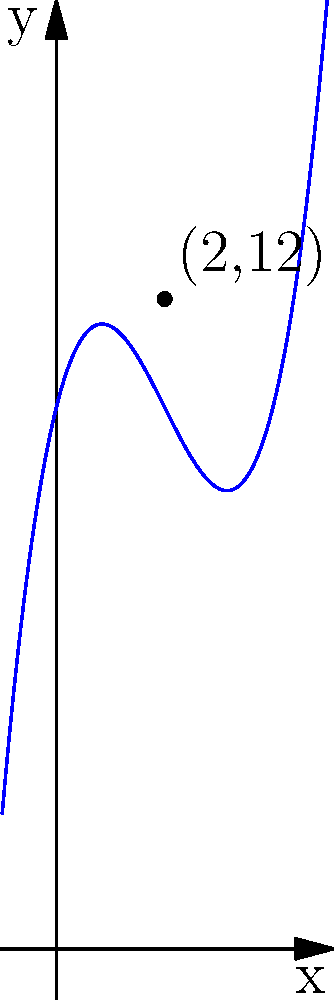A prestigious library's rare manuscript collection is growing according to the cubic function $f(x) = 0.5x^3 - 3x^2 + 4x + 10$, where $x$ represents years since the collection's inception and $f(x)$ represents the number of manuscripts. After how many years will the collection reach 12 manuscripts, and what does this reveal about the collection's growth pattern? To solve this problem, we need to find the value of $x$ when $f(x) = 12$. Let's approach this step-by-step:

1) We need to solve the equation:
   $0.5x^3 - 3x^2 + 4x + 10 = 12$

2) Simplify by subtracting 12 from both sides:
   $0.5x^3 - 3x^2 + 4x - 2 = 0$

3) This cubic equation doesn't factor easily, but we can see from the graph that $x = 2$ is a solution.

4) We can verify this algebraically:
   $f(2) = 0.5(2)^3 - 3(2)^2 + 4(2) + 10$
         $= 0.5(8) - 3(4) + 8 + 10$
         $= 4 - 12 + 8 + 10$
         $= 12$

5) The collection will reach 12 manuscripts after 2 years.

6) Analyzing the growth pattern:
   - The function is cubic, indicating a complex growth pattern.
   - Initially, growth is slow (concave up part of the curve).
   - Around the 2-year mark, growth temporarily stagnates (inflection point).
   - After this point, growth accelerates rapidly (concave up again).

This pattern suggests an initial period of establishment, followed by a brief plateau, and then rapid expansion, possibly due to increased recognition or resources.
Answer: 2 years; indicates initial slow growth, brief stagnation, then rapid acceleration. 